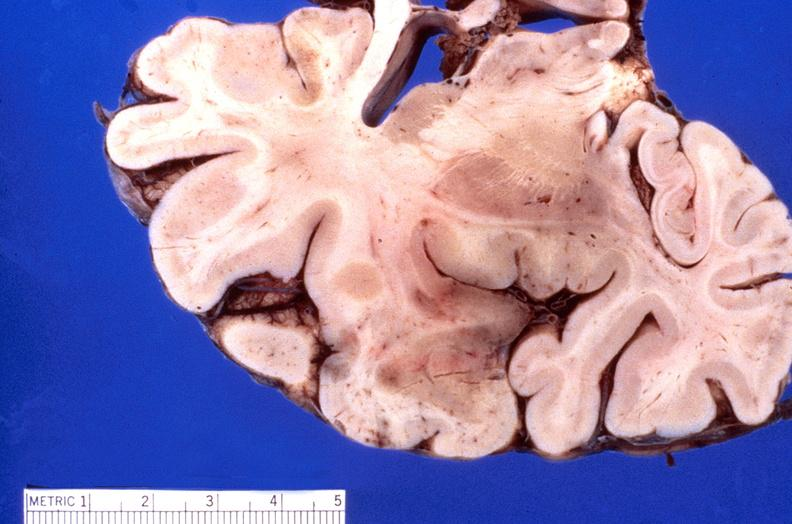what does this image show?
Answer the question using a single word or phrase. Brain 